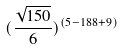Convert formula to latex. <formula><loc_0><loc_0><loc_500><loc_500>( \frac { \sqrt { 1 5 0 } } { 6 } ) ^ { ( 5 - 1 8 8 + 9 ) }</formula> 